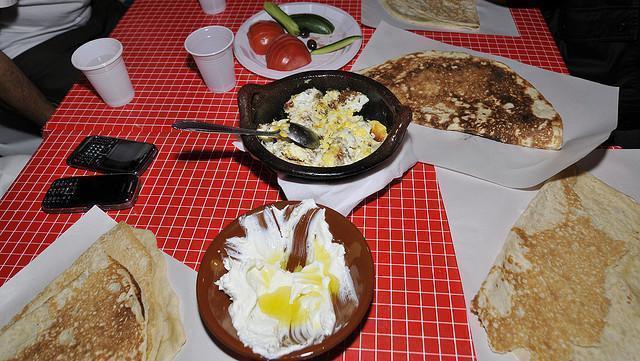This meal is likely for how many people?
Select the accurate answer and provide justification: `Answer: choice
Rationale: srationale.`
Options: Two, five, thirty, one. Answer: two.
Rationale: There is too much food for one person, but not really enough for more than two. 